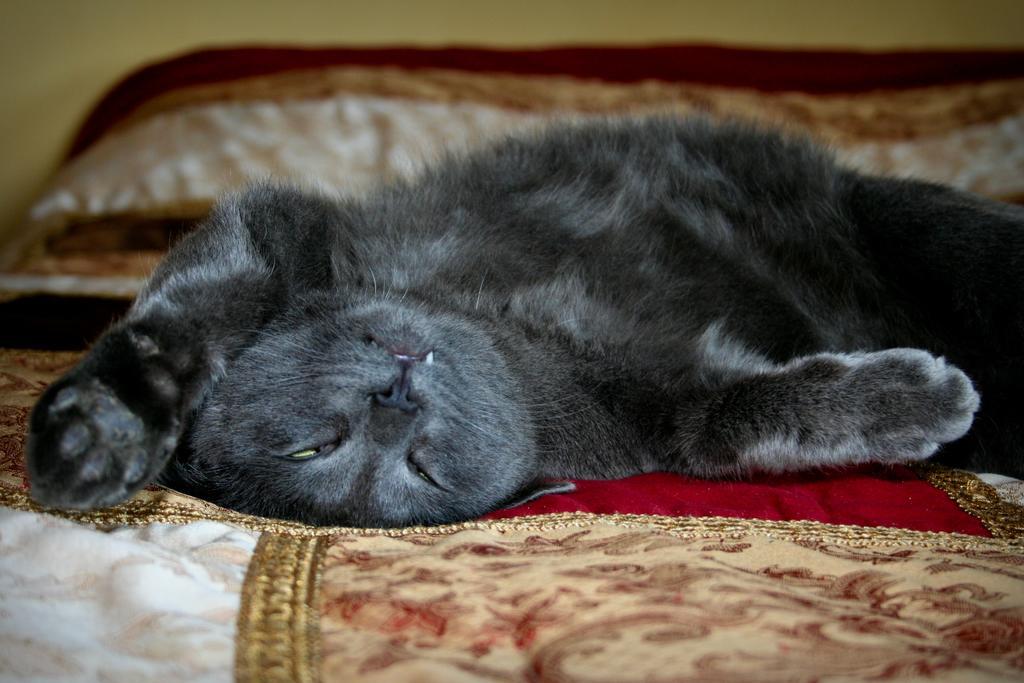Describe this image in one or two sentences. In the center of the image, we can see a cat lying on the bed and in the background, there is a wall. 